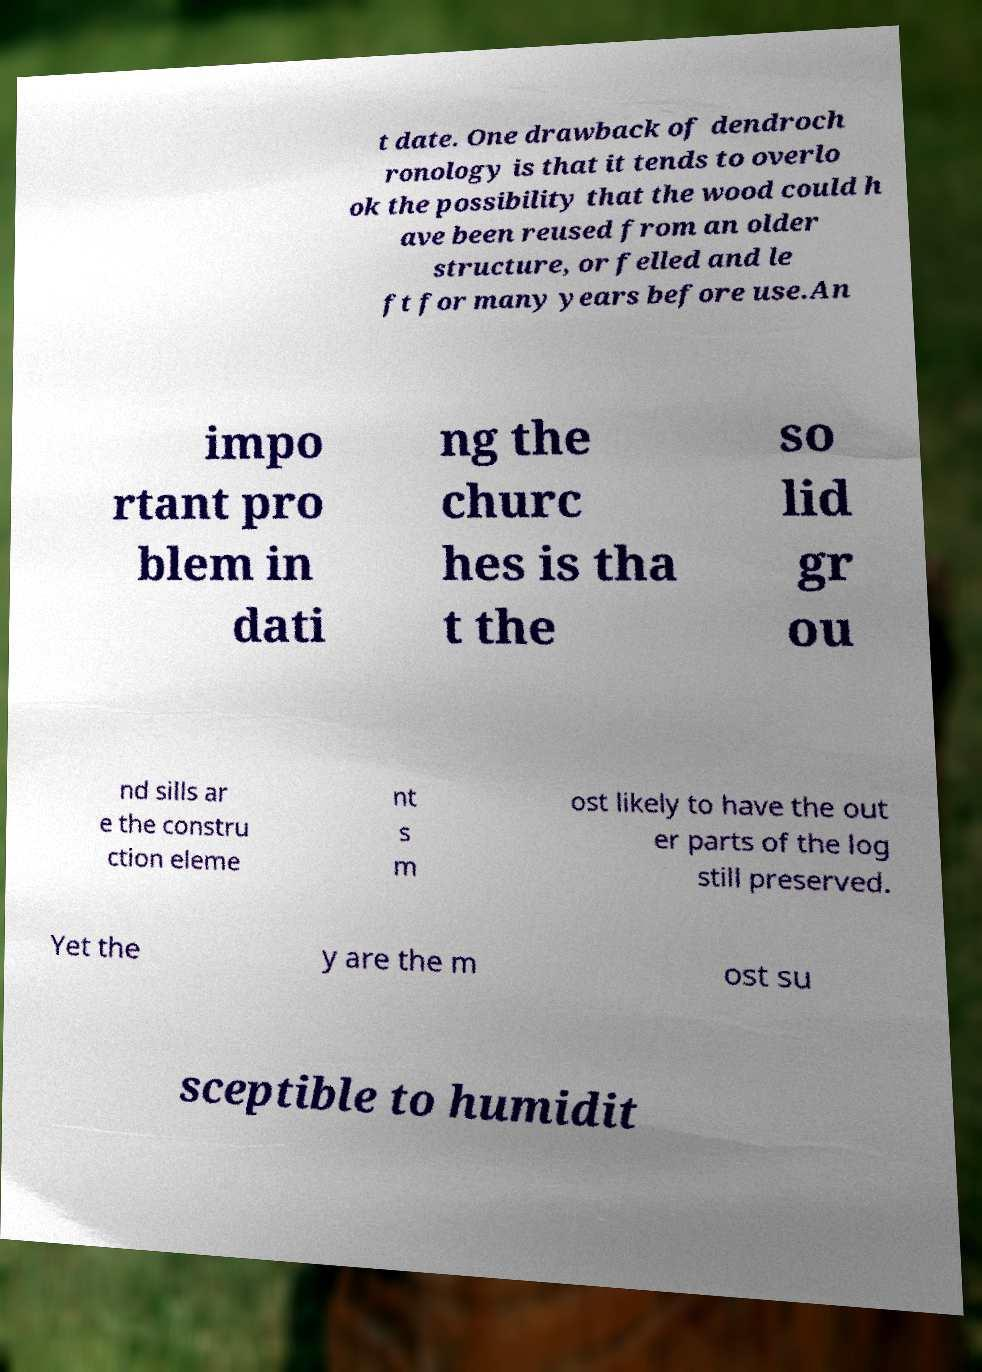There's text embedded in this image that I need extracted. Can you transcribe it verbatim? t date. One drawback of dendroch ronology is that it tends to overlo ok the possibility that the wood could h ave been reused from an older structure, or felled and le ft for many years before use.An impo rtant pro blem in dati ng the churc hes is tha t the so lid gr ou nd sills ar e the constru ction eleme nt s m ost likely to have the out er parts of the log still preserved. Yet the y are the m ost su sceptible to humidit 